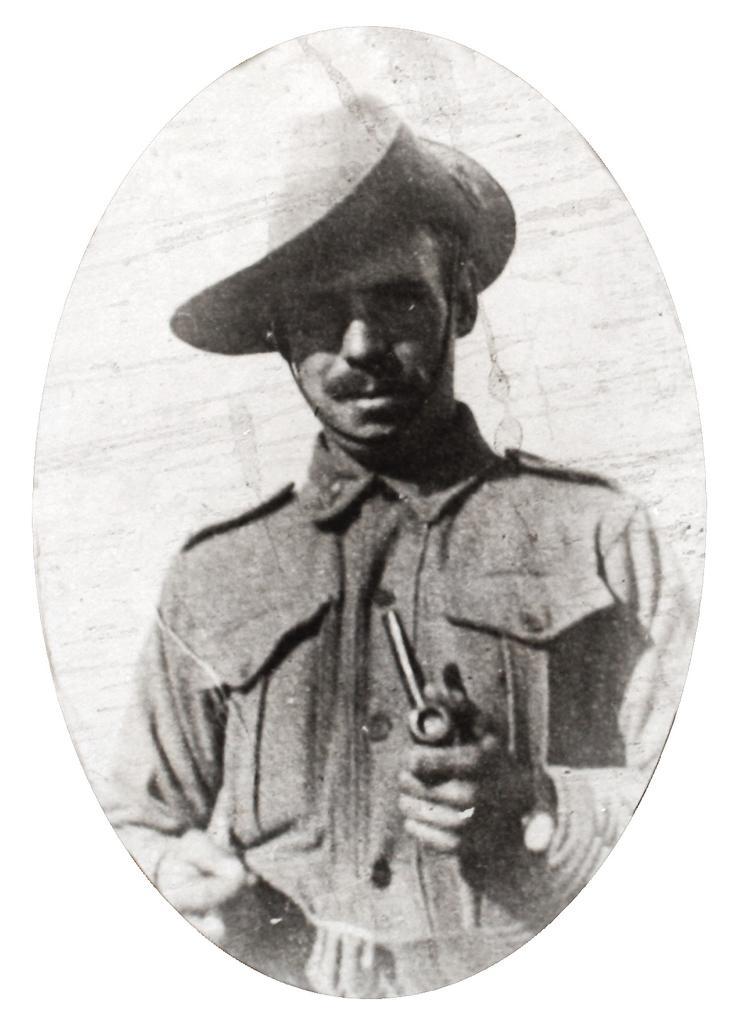Please provide a concise description of this image. In this image I can see a person wearing cap and holding something. The image is in black and white. 